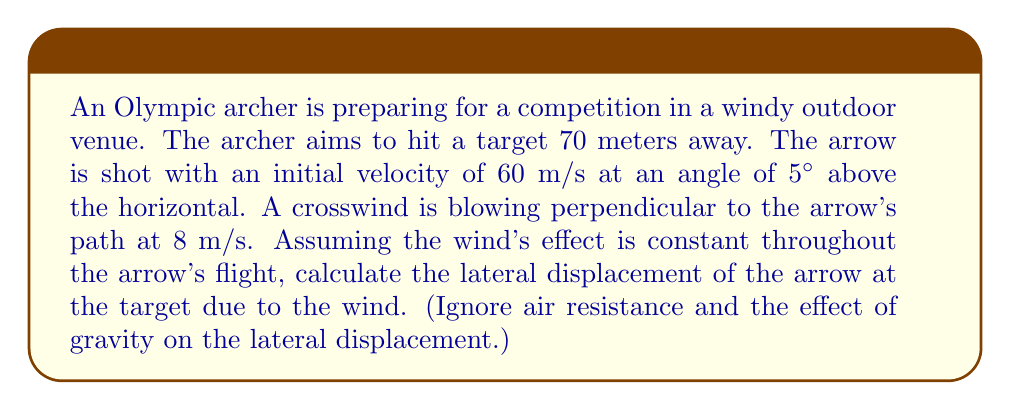What is the answer to this math problem? To solve this problem, we need to break it down into steps using vector components:

1) First, let's calculate the time of flight for the arrow:
   - The horizontal component of the arrow's velocity is:
     $$v_x = 60 \cos(5°) \approx 59.77 \text{ m/s}$$
   - Time of flight:
     $$t = \frac{\text{distance}}{\text{horizontal velocity}} = \frac{70 \text{ m}}{59.77 \text{ m/s}} \approx 1.17 \text{ s}$$

2) Now, we consider the effect of the wind:
   - The wind velocity is perpendicular to the arrow's path, so it only affects the lateral displacement.
   - The lateral displacement due to wind can be calculated using the equation:
     $$d = v_w \cdot t$$
   where $d$ is displacement, $v_w$ is wind velocity, and $t$ is time of flight.

3) Plugging in our values:
   $$d = 8 \text{ m/s} \cdot 1.17 \text{ s} \approx 9.36 \text{ m}$$

Therefore, the lateral displacement of the arrow at the target due to the wind is approximately 9.36 meters.
Answer: The lateral displacement of the arrow at the target due to the wind is approximately 9.36 meters. 